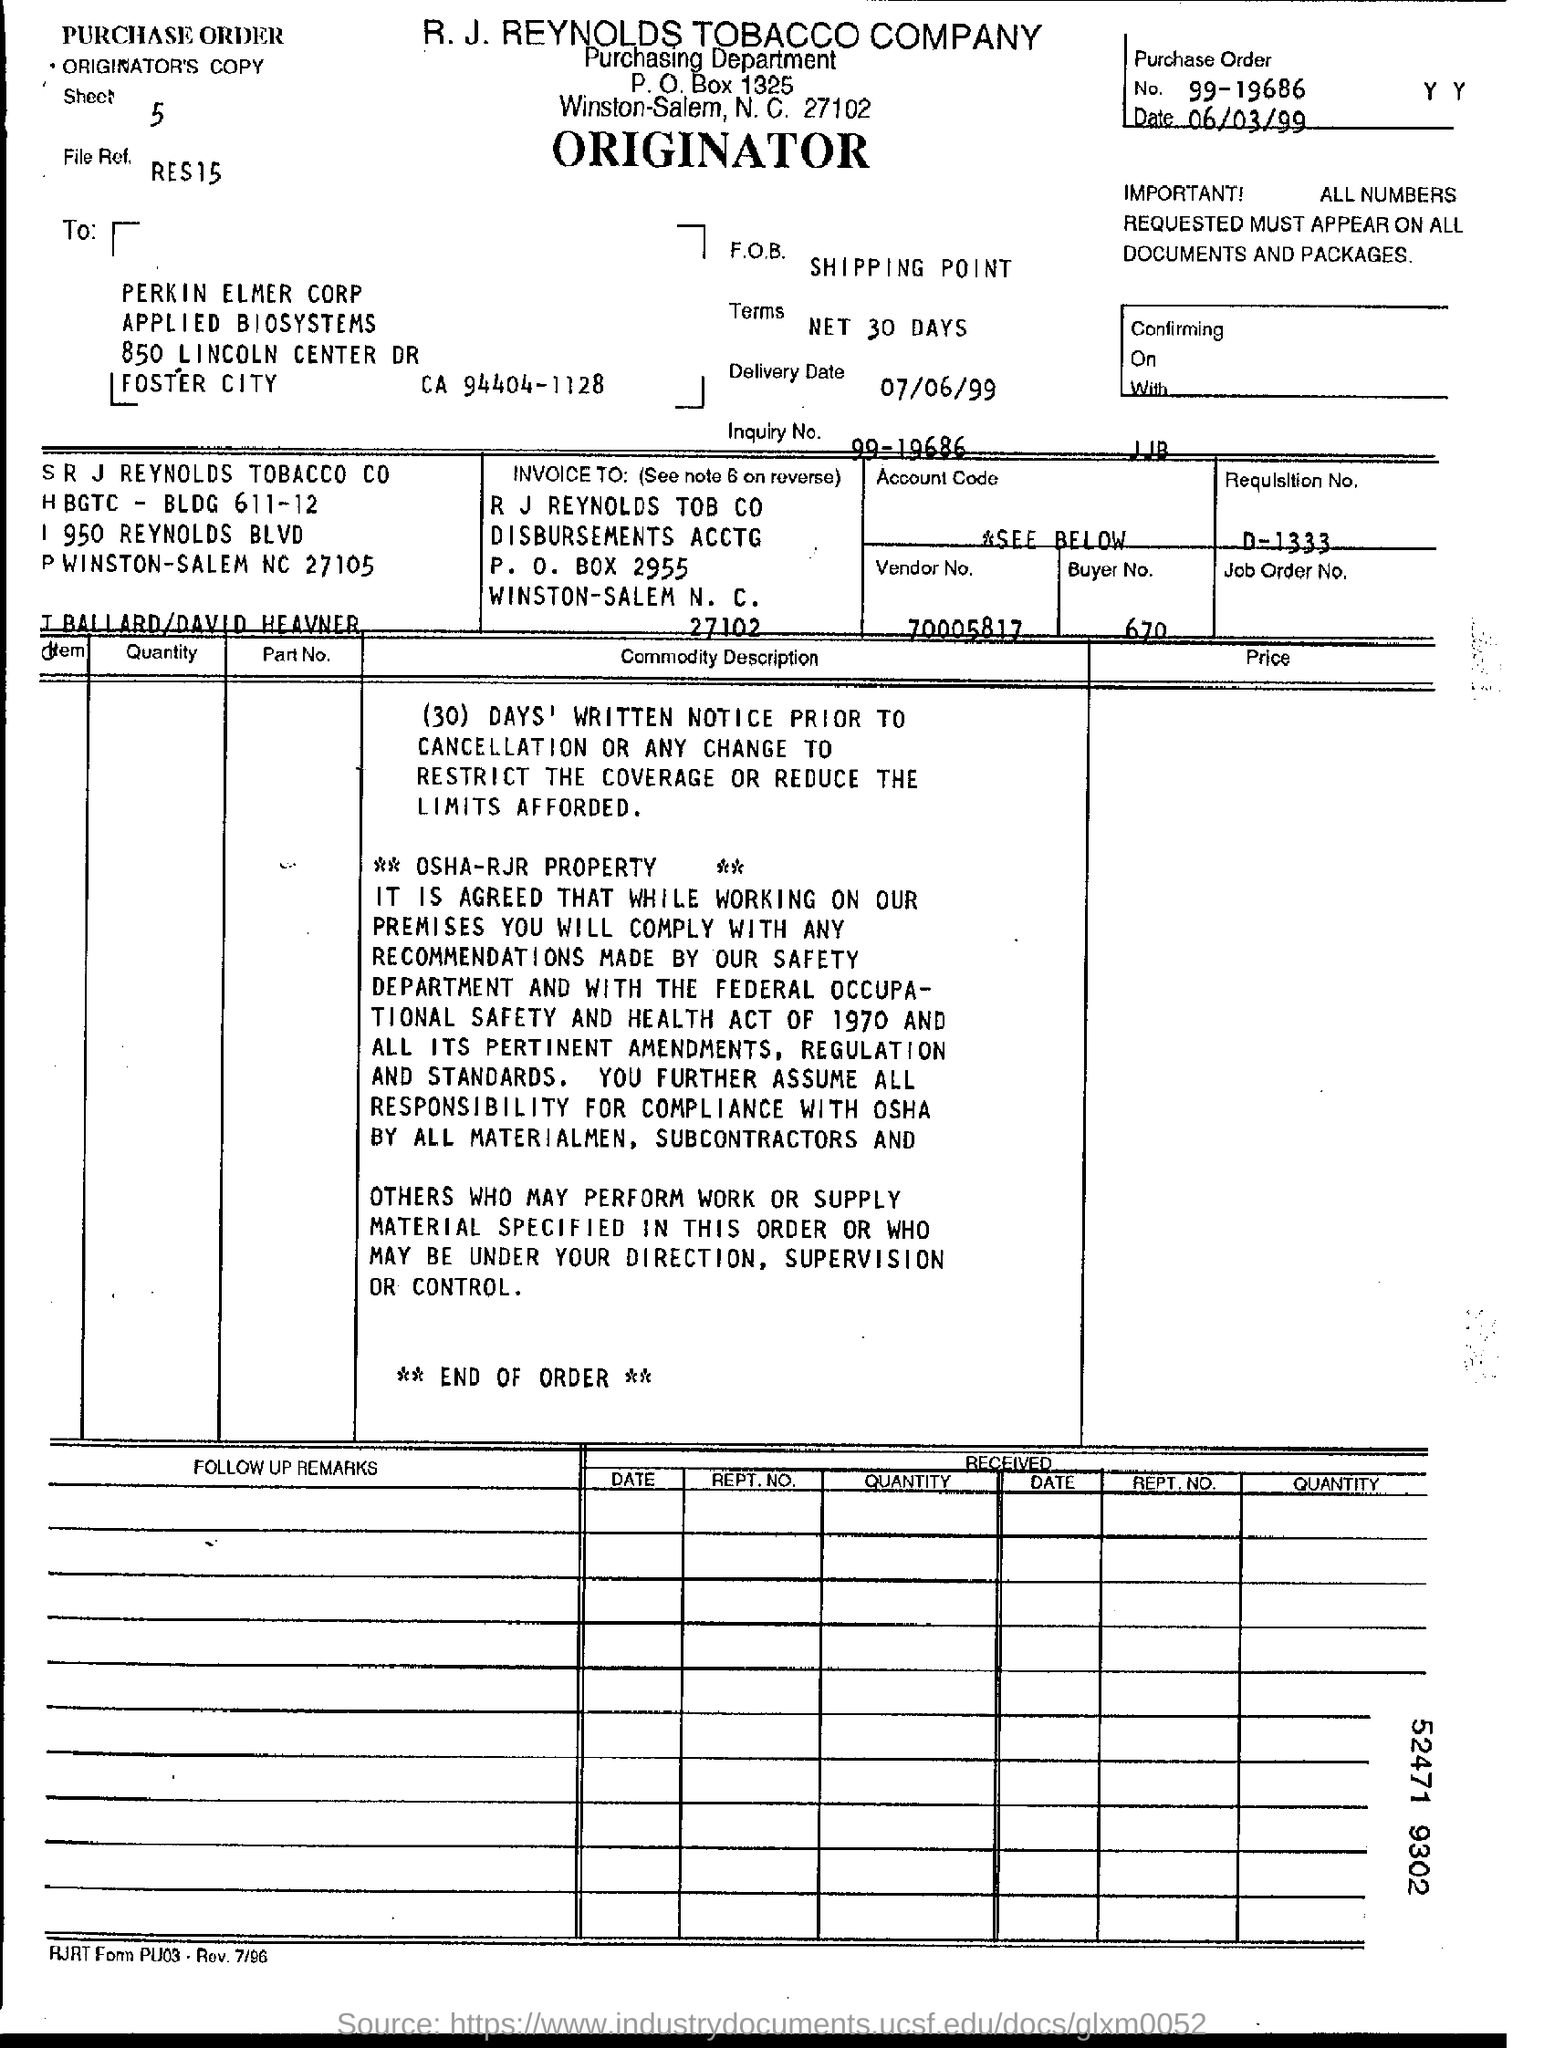What is the purchase order number?
Ensure brevity in your answer.  99-19686. What is the vendor number?
Ensure brevity in your answer.  70005817. What is the buyer number?
Make the answer very short. 670. What is the requlsltion number?
Give a very brief answer. D-1333. What is the p.o box number?
Give a very brief answer. 2955. 